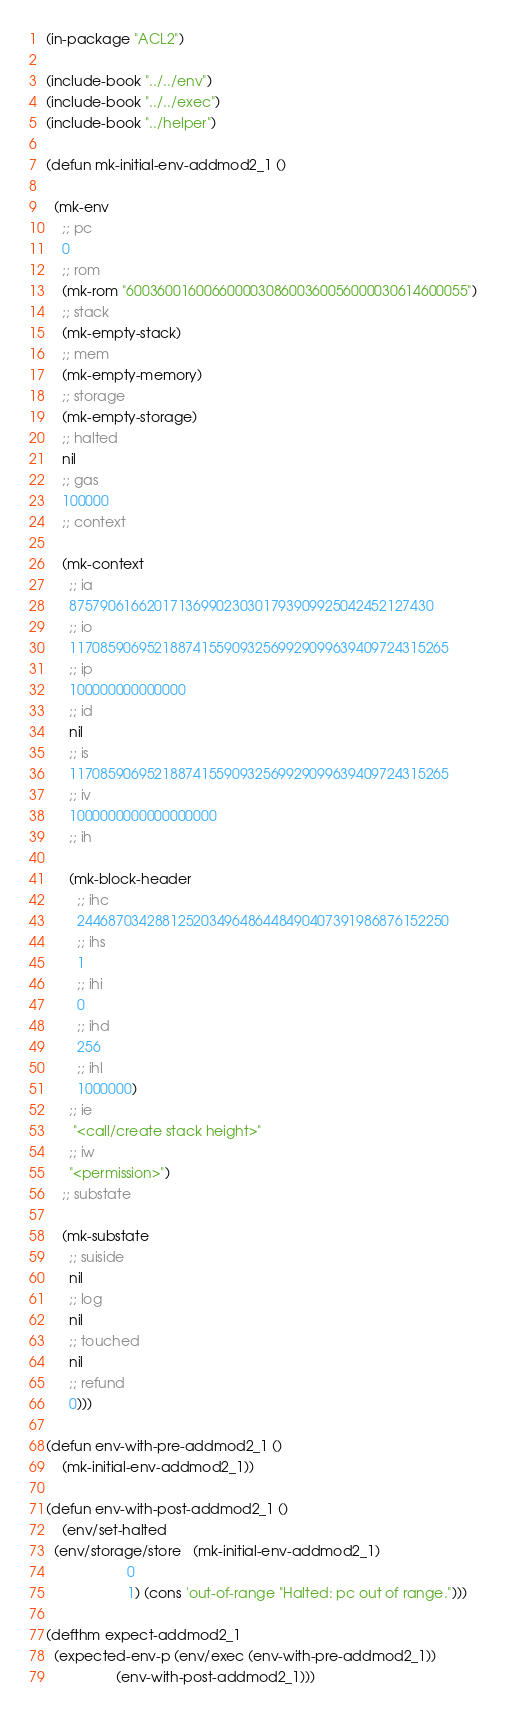Convert code to text. <code><loc_0><loc_0><loc_500><loc_500><_Lisp_>
(in-package "ACL2")

(include-book "../../env")
(include-book "../../exec")
(include-book "../helper")

(defun mk-initial-env-addmod2_1 ()

  (mk-env
    ;; pc
    0
    ;; rom
    (mk-rom "60036001600660000308600360056000030614600055")
    ;; stack
    (mk-empty-stack)
    ;; mem
    (mk-empty-memory)
    ;; storage
    (mk-empty-storage)
    ;; halted
    nil
    ;; gas
    100000
    ;; context
  
    (mk-context
      ;; ia
      87579061662017136990230301793909925042452127430
      ;; io
      1170859069521887415590932569929099639409724315265
      ;; ip
      100000000000000
      ;; id
      nil
      ;; is
      1170859069521887415590932569929099639409724315265
      ;; iv
      1000000000000000000
      ;; ih
  
      (mk-block-header
        ;; ihc
        244687034288125203496486448490407391986876152250
        ;; ihs
        1
        ;; ihi
        0
        ;; ihd
        256
        ;; ihl
        1000000)
      ;; ie
       "<call/create stack height>"
      ;; iw
      "<permission>")
    ;; substate
  
    (mk-substate
      ;; suiside
      nil
      ;; log
      nil
      ;; touched
      nil
      ;; refund
      0)))

(defun env-with-pre-addmod2_1 ()
    (mk-initial-env-addmod2_1))

(defun env-with-post-addmod2_1 ()
    (env/set-halted 
  (env/storage/store   (mk-initial-env-addmod2_1)
                     0
                     1) (cons 'out-of-range "Halted: pc out of range.")))

(defthm expect-addmod2_1
  (expected-env-p (env/exec (env-with-pre-addmod2_1))
                  (env-with-post-addmod2_1)))</code> 